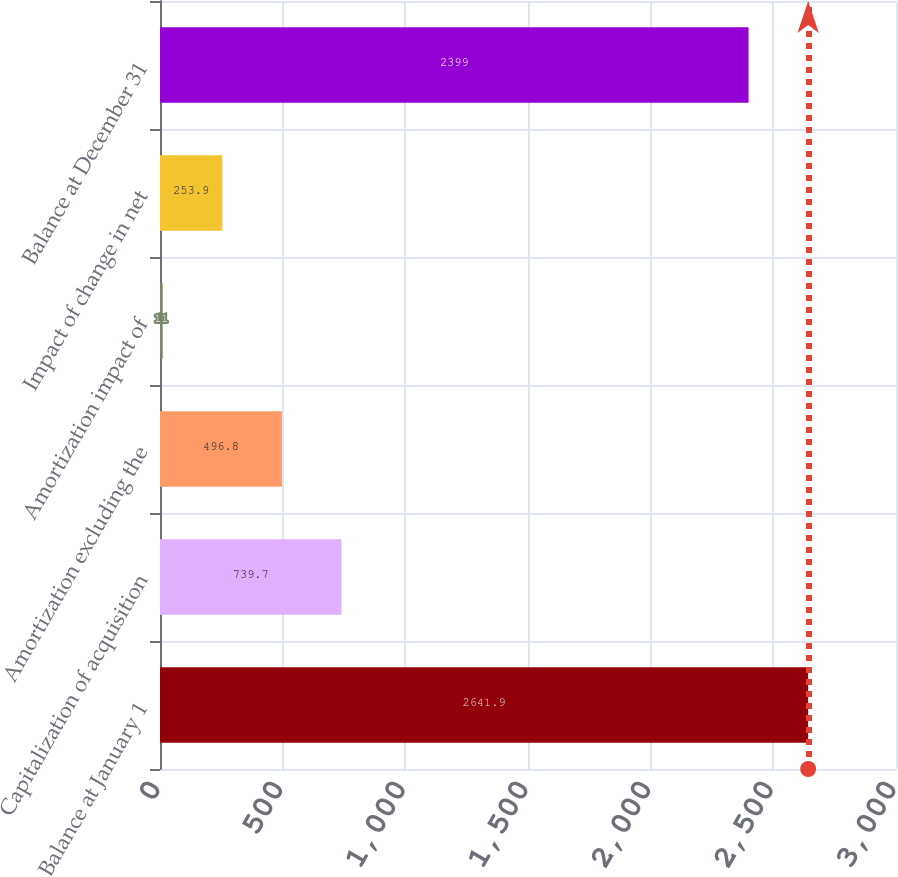Convert chart. <chart><loc_0><loc_0><loc_500><loc_500><bar_chart><fcel>Balance at January 1<fcel>Capitalization of acquisition<fcel>Amortization excluding the<fcel>Amortization impact of<fcel>Impact of change in net<fcel>Balance at December 31<nl><fcel>2641.9<fcel>739.7<fcel>496.8<fcel>11<fcel>253.9<fcel>2399<nl></chart> 